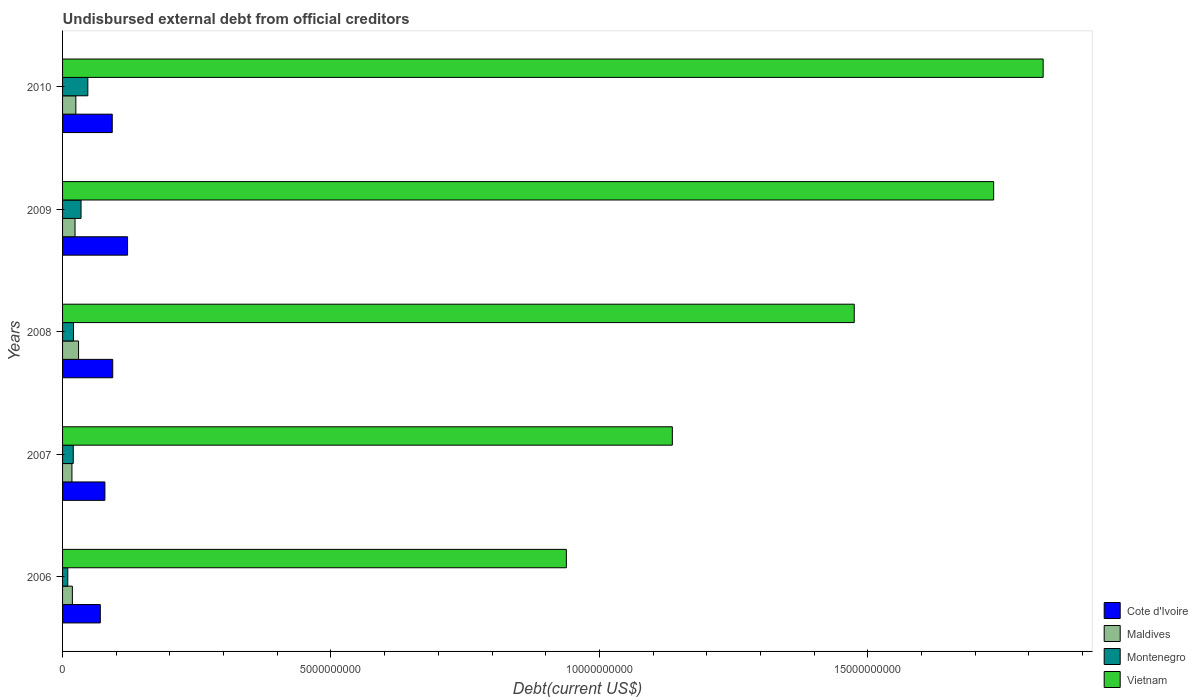How many different coloured bars are there?
Provide a short and direct response. 4. How many groups of bars are there?
Provide a short and direct response. 5. Are the number of bars on each tick of the Y-axis equal?
Keep it short and to the point. Yes. In how many cases, is the number of bars for a given year not equal to the number of legend labels?
Your answer should be very brief. 0. What is the total debt in Vietnam in 2008?
Ensure brevity in your answer.  1.47e+1. Across all years, what is the maximum total debt in Montenegro?
Your answer should be very brief. 4.71e+08. Across all years, what is the minimum total debt in Maldives?
Provide a short and direct response. 1.75e+08. In which year was the total debt in Maldives maximum?
Provide a succinct answer. 2008. In which year was the total debt in Cote d'Ivoire minimum?
Make the answer very short. 2006. What is the total total debt in Maldives in the graph?
Your answer should be very brief. 1.14e+09. What is the difference between the total debt in Cote d'Ivoire in 2007 and that in 2008?
Give a very brief answer. -1.46e+08. What is the difference between the total debt in Maldives in 2006 and the total debt in Montenegro in 2009?
Make the answer very short. -1.61e+08. What is the average total debt in Vietnam per year?
Ensure brevity in your answer.  1.42e+1. In the year 2009, what is the difference between the total debt in Maldives and total debt in Montenegro?
Give a very brief answer. -1.12e+08. In how many years, is the total debt in Cote d'Ivoire greater than 15000000000 US$?
Provide a succinct answer. 0. What is the ratio of the total debt in Montenegro in 2007 to that in 2010?
Give a very brief answer. 0.42. Is the total debt in Montenegro in 2008 less than that in 2009?
Your answer should be very brief. Yes. What is the difference between the highest and the second highest total debt in Montenegro?
Provide a short and direct response. 1.27e+08. What is the difference between the highest and the lowest total debt in Montenegro?
Your answer should be very brief. 3.74e+08. In how many years, is the total debt in Montenegro greater than the average total debt in Montenegro taken over all years?
Your response must be concise. 2. Is it the case that in every year, the sum of the total debt in Montenegro and total debt in Vietnam is greater than the sum of total debt in Cote d'Ivoire and total debt in Maldives?
Give a very brief answer. Yes. What does the 4th bar from the top in 2008 represents?
Offer a terse response. Cote d'Ivoire. What does the 1st bar from the bottom in 2006 represents?
Give a very brief answer. Cote d'Ivoire. Are all the bars in the graph horizontal?
Your answer should be very brief. Yes. How many years are there in the graph?
Keep it short and to the point. 5. Does the graph contain any zero values?
Keep it short and to the point. No. Does the graph contain grids?
Your response must be concise. No. Where does the legend appear in the graph?
Provide a succinct answer. Bottom right. How are the legend labels stacked?
Offer a very short reply. Vertical. What is the title of the graph?
Give a very brief answer. Undisbursed external debt from official creditors. Does "Zimbabwe" appear as one of the legend labels in the graph?
Offer a terse response. No. What is the label or title of the X-axis?
Provide a succinct answer. Debt(current US$). What is the label or title of the Y-axis?
Keep it short and to the point. Years. What is the Debt(current US$) of Cote d'Ivoire in 2006?
Ensure brevity in your answer.  7.03e+08. What is the Debt(current US$) in Maldives in 2006?
Give a very brief answer. 1.83e+08. What is the Debt(current US$) of Montenegro in 2006?
Your answer should be very brief. 9.70e+07. What is the Debt(current US$) in Vietnam in 2006?
Make the answer very short. 9.38e+09. What is the Debt(current US$) in Cote d'Ivoire in 2007?
Your answer should be compact. 7.89e+08. What is the Debt(current US$) in Maldives in 2007?
Give a very brief answer. 1.75e+08. What is the Debt(current US$) of Montenegro in 2007?
Provide a short and direct response. 1.99e+08. What is the Debt(current US$) of Vietnam in 2007?
Offer a terse response. 1.14e+1. What is the Debt(current US$) in Cote d'Ivoire in 2008?
Ensure brevity in your answer.  9.35e+08. What is the Debt(current US$) in Maldives in 2008?
Your answer should be compact. 2.98e+08. What is the Debt(current US$) in Montenegro in 2008?
Offer a terse response. 2.04e+08. What is the Debt(current US$) of Vietnam in 2008?
Make the answer very short. 1.47e+1. What is the Debt(current US$) in Cote d'Ivoire in 2009?
Offer a very short reply. 1.21e+09. What is the Debt(current US$) in Maldives in 2009?
Give a very brief answer. 2.32e+08. What is the Debt(current US$) in Montenegro in 2009?
Give a very brief answer. 3.44e+08. What is the Debt(current US$) of Vietnam in 2009?
Your answer should be very brief. 1.73e+1. What is the Debt(current US$) of Cote d'Ivoire in 2010?
Give a very brief answer. 9.25e+08. What is the Debt(current US$) of Maldives in 2010?
Give a very brief answer. 2.48e+08. What is the Debt(current US$) of Montenegro in 2010?
Offer a terse response. 4.71e+08. What is the Debt(current US$) in Vietnam in 2010?
Give a very brief answer. 1.83e+1. Across all years, what is the maximum Debt(current US$) in Cote d'Ivoire?
Your answer should be compact. 1.21e+09. Across all years, what is the maximum Debt(current US$) in Maldives?
Make the answer very short. 2.98e+08. Across all years, what is the maximum Debt(current US$) of Montenegro?
Give a very brief answer. 4.71e+08. Across all years, what is the maximum Debt(current US$) of Vietnam?
Give a very brief answer. 1.83e+1. Across all years, what is the minimum Debt(current US$) in Cote d'Ivoire?
Offer a terse response. 7.03e+08. Across all years, what is the minimum Debt(current US$) of Maldives?
Your response must be concise. 1.75e+08. Across all years, what is the minimum Debt(current US$) of Montenegro?
Your response must be concise. 9.70e+07. Across all years, what is the minimum Debt(current US$) in Vietnam?
Ensure brevity in your answer.  9.38e+09. What is the total Debt(current US$) of Cote d'Ivoire in the graph?
Your response must be concise. 4.56e+09. What is the total Debt(current US$) in Maldives in the graph?
Your answer should be very brief. 1.14e+09. What is the total Debt(current US$) of Montenegro in the graph?
Provide a succinct answer. 1.31e+09. What is the total Debt(current US$) of Vietnam in the graph?
Provide a succinct answer. 7.11e+1. What is the difference between the Debt(current US$) in Cote d'Ivoire in 2006 and that in 2007?
Offer a very short reply. -8.53e+07. What is the difference between the Debt(current US$) of Maldives in 2006 and that in 2007?
Provide a succinct answer. 8.20e+06. What is the difference between the Debt(current US$) of Montenegro in 2006 and that in 2007?
Give a very brief answer. -1.02e+08. What is the difference between the Debt(current US$) in Vietnam in 2006 and that in 2007?
Offer a terse response. -1.97e+09. What is the difference between the Debt(current US$) of Cote d'Ivoire in 2006 and that in 2008?
Offer a terse response. -2.31e+08. What is the difference between the Debt(current US$) of Maldives in 2006 and that in 2008?
Your answer should be compact. -1.15e+08. What is the difference between the Debt(current US$) in Montenegro in 2006 and that in 2008?
Provide a short and direct response. -1.07e+08. What is the difference between the Debt(current US$) in Vietnam in 2006 and that in 2008?
Make the answer very short. -5.36e+09. What is the difference between the Debt(current US$) of Cote d'Ivoire in 2006 and that in 2009?
Your response must be concise. -5.08e+08. What is the difference between the Debt(current US$) in Maldives in 2006 and that in 2009?
Provide a short and direct response. -4.94e+07. What is the difference between the Debt(current US$) in Montenegro in 2006 and that in 2009?
Offer a terse response. -2.47e+08. What is the difference between the Debt(current US$) in Vietnam in 2006 and that in 2009?
Offer a terse response. -7.96e+09. What is the difference between the Debt(current US$) of Cote d'Ivoire in 2006 and that in 2010?
Ensure brevity in your answer.  -2.22e+08. What is the difference between the Debt(current US$) of Maldives in 2006 and that in 2010?
Your answer should be very brief. -6.49e+07. What is the difference between the Debt(current US$) of Montenegro in 2006 and that in 2010?
Offer a terse response. -3.74e+08. What is the difference between the Debt(current US$) of Vietnam in 2006 and that in 2010?
Give a very brief answer. -8.88e+09. What is the difference between the Debt(current US$) in Cote d'Ivoire in 2007 and that in 2008?
Provide a short and direct response. -1.46e+08. What is the difference between the Debt(current US$) of Maldives in 2007 and that in 2008?
Offer a terse response. -1.24e+08. What is the difference between the Debt(current US$) of Montenegro in 2007 and that in 2008?
Provide a short and direct response. -4.64e+06. What is the difference between the Debt(current US$) of Vietnam in 2007 and that in 2008?
Your answer should be compact. -3.39e+09. What is the difference between the Debt(current US$) in Cote d'Ivoire in 2007 and that in 2009?
Provide a short and direct response. -4.22e+08. What is the difference between the Debt(current US$) of Maldives in 2007 and that in 2009?
Keep it short and to the point. -5.76e+07. What is the difference between the Debt(current US$) of Montenegro in 2007 and that in 2009?
Offer a terse response. -1.45e+08. What is the difference between the Debt(current US$) in Vietnam in 2007 and that in 2009?
Offer a terse response. -5.99e+09. What is the difference between the Debt(current US$) of Cote d'Ivoire in 2007 and that in 2010?
Ensure brevity in your answer.  -1.37e+08. What is the difference between the Debt(current US$) of Maldives in 2007 and that in 2010?
Your answer should be very brief. -7.31e+07. What is the difference between the Debt(current US$) in Montenegro in 2007 and that in 2010?
Your answer should be compact. -2.72e+08. What is the difference between the Debt(current US$) in Vietnam in 2007 and that in 2010?
Ensure brevity in your answer.  -6.91e+09. What is the difference between the Debt(current US$) of Cote d'Ivoire in 2008 and that in 2009?
Ensure brevity in your answer.  -2.76e+08. What is the difference between the Debt(current US$) in Maldives in 2008 and that in 2009?
Provide a short and direct response. 6.60e+07. What is the difference between the Debt(current US$) of Montenegro in 2008 and that in 2009?
Your answer should be compact. -1.40e+08. What is the difference between the Debt(current US$) of Vietnam in 2008 and that in 2009?
Keep it short and to the point. -2.60e+09. What is the difference between the Debt(current US$) of Cote d'Ivoire in 2008 and that in 2010?
Ensure brevity in your answer.  9.16e+06. What is the difference between the Debt(current US$) in Maldives in 2008 and that in 2010?
Your response must be concise. 5.04e+07. What is the difference between the Debt(current US$) of Montenegro in 2008 and that in 2010?
Provide a succinct answer. -2.67e+08. What is the difference between the Debt(current US$) of Vietnam in 2008 and that in 2010?
Provide a short and direct response. -3.52e+09. What is the difference between the Debt(current US$) of Cote d'Ivoire in 2009 and that in 2010?
Your response must be concise. 2.85e+08. What is the difference between the Debt(current US$) of Maldives in 2009 and that in 2010?
Ensure brevity in your answer.  -1.55e+07. What is the difference between the Debt(current US$) of Montenegro in 2009 and that in 2010?
Keep it short and to the point. -1.27e+08. What is the difference between the Debt(current US$) of Vietnam in 2009 and that in 2010?
Give a very brief answer. -9.22e+08. What is the difference between the Debt(current US$) in Cote d'Ivoire in 2006 and the Debt(current US$) in Maldives in 2007?
Provide a succinct answer. 5.29e+08. What is the difference between the Debt(current US$) in Cote d'Ivoire in 2006 and the Debt(current US$) in Montenegro in 2007?
Offer a very short reply. 5.04e+08. What is the difference between the Debt(current US$) of Cote d'Ivoire in 2006 and the Debt(current US$) of Vietnam in 2007?
Keep it short and to the point. -1.07e+1. What is the difference between the Debt(current US$) in Maldives in 2006 and the Debt(current US$) in Montenegro in 2007?
Offer a very short reply. -1.63e+07. What is the difference between the Debt(current US$) in Maldives in 2006 and the Debt(current US$) in Vietnam in 2007?
Make the answer very short. -1.12e+1. What is the difference between the Debt(current US$) in Montenegro in 2006 and the Debt(current US$) in Vietnam in 2007?
Ensure brevity in your answer.  -1.13e+1. What is the difference between the Debt(current US$) in Cote d'Ivoire in 2006 and the Debt(current US$) in Maldives in 2008?
Your response must be concise. 4.05e+08. What is the difference between the Debt(current US$) in Cote d'Ivoire in 2006 and the Debt(current US$) in Montenegro in 2008?
Your answer should be compact. 5.00e+08. What is the difference between the Debt(current US$) of Cote d'Ivoire in 2006 and the Debt(current US$) of Vietnam in 2008?
Provide a succinct answer. -1.40e+1. What is the difference between the Debt(current US$) of Maldives in 2006 and the Debt(current US$) of Montenegro in 2008?
Your response must be concise. -2.10e+07. What is the difference between the Debt(current US$) of Maldives in 2006 and the Debt(current US$) of Vietnam in 2008?
Your answer should be very brief. -1.46e+1. What is the difference between the Debt(current US$) in Montenegro in 2006 and the Debt(current US$) in Vietnam in 2008?
Make the answer very short. -1.47e+1. What is the difference between the Debt(current US$) in Cote d'Ivoire in 2006 and the Debt(current US$) in Maldives in 2009?
Provide a succinct answer. 4.71e+08. What is the difference between the Debt(current US$) in Cote d'Ivoire in 2006 and the Debt(current US$) in Montenegro in 2009?
Your response must be concise. 3.59e+08. What is the difference between the Debt(current US$) of Cote d'Ivoire in 2006 and the Debt(current US$) of Vietnam in 2009?
Keep it short and to the point. -1.66e+1. What is the difference between the Debt(current US$) of Maldives in 2006 and the Debt(current US$) of Montenegro in 2009?
Make the answer very short. -1.61e+08. What is the difference between the Debt(current US$) in Maldives in 2006 and the Debt(current US$) in Vietnam in 2009?
Your answer should be compact. -1.72e+1. What is the difference between the Debt(current US$) of Montenegro in 2006 and the Debt(current US$) of Vietnam in 2009?
Offer a very short reply. -1.72e+1. What is the difference between the Debt(current US$) in Cote d'Ivoire in 2006 and the Debt(current US$) in Maldives in 2010?
Offer a very short reply. 4.56e+08. What is the difference between the Debt(current US$) in Cote d'Ivoire in 2006 and the Debt(current US$) in Montenegro in 2010?
Your response must be concise. 2.33e+08. What is the difference between the Debt(current US$) of Cote d'Ivoire in 2006 and the Debt(current US$) of Vietnam in 2010?
Offer a terse response. -1.76e+1. What is the difference between the Debt(current US$) of Maldives in 2006 and the Debt(current US$) of Montenegro in 2010?
Offer a terse response. -2.88e+08. What is the difference between the Debt(current US$) in Maldives in 2006 and the Debt(current US$) in Vietnam in 2010?
Provide a short and direct response. -1.81e+1. What is the difference between the Debt(current US$) in Montenegro in 2006 and the Debt(current US$) in Vietnam in 2010?
Your answer should be very brief. -1.82e+1. What is the difference between the Debt(current US$) of Cote d'Ivoire in 2007 and the Debt(current US$) of Maldives in 2008?
Your answer should be very brief. 4.91e+08. What is the difference between the Debt(current US$) of Cote d'Ivoire in 2007 and the Debt(current US$) of Montenegro in 2008?
Make the answer very short. 5.85e+08. What is the difference between the Debt(current US$) in Cote d'Ivoire in 2007 and the Debt(current US$) in Vietnam in 2008?
Offer a terse response. -1.40e+1. What is the difference between the Debt(current US$) of Maldives in 2007 and the Debt(current US$) of Montenegro in 2008?
Give a very brief answer. -2.92e+07. What is the difference between the Debt(current US$) of Maldives in 2007 and the Debt(current US$) of Vietnam in 2008?
Offer a very short reply. -1.46e+1. What is the difference between the Debt(current US$) of Montenegro in 2007 and the Debt(current US$) of Vietnam in 2008?
Offer a very short reply. -1.45e+1. What is the difference between the Debt(current US$) of Cote d'Ivoire in 2007 and the Debt(current US$) of Maldives in 2009?
Your response must be concise. 5.57e+08. What is the difference between the Debt(current US$) in Cote d'Ivoire in 2007 and the Debt(current US$) in Montenegro in 2009?
Provide a succinct answer. 4.45e+08. What is the difference between the Debt(current US$) in Cote d'Ivoire in 2007 and the Debt(current US$) in Vietnam in 2009?
Give a very brief answer. -1.66e+1. What is the difference between the Debt(current US$) of Maldives in 2007 and the Debt(current US$) of Montenegro in 2009?
Give a very brief answer. -1.69e+08. What is the difference between the Debt(current US$) of Maldives in 2007 and the Debt(current US$) of Vietnam in 2009?
Offer a terse response. -1.72e+1. What is the difference between the Debt(current US$) of Montenegro in 2007 and the Debt(current US$) of Vietnam in 2009?
Make the answer very short. -1.71e+1. What is the difference between the Debt(current US$) in Cote d'Ivoire in 2007 and the Debt(current US$) in Maldives in 2010?
Make the answer very short. 5.41e+08. What is the difference between the Debt(current US$) in Cote d'Ivoire in 2007 and the Debt(current US$) in Montenegro in 2010?
Keep it short and to the point. 3.18e+08. What is the difference between the Debt(current US$) of Cote d'Ivoire in 2007 and the Debt(current US$) of Vietnam in 2010?
Provide a succinct answer. -1.75e+1. What is the difference between the Debt(current US$) in Maldives in 2007 and the Debt(current US$) in Montenegro in 2010?
Offer a very short reply. -2.96e+08. What is the difference between the Debt(current US$) of Maldives in 2007 and the Debt(current US$) of Vietnam in 2010?
Make the answer very short. -1.81e+1. What is the difference between the Debt(current US$) in Montenegro in 2007 and the Debt(current US$) in Vietnam in 2010?
Provide a short and direct response. -1.81e+1. What is the difference between the Debt(current US$) of Cote d'Ivoire in 2008 and the Debt(current US$) of Maldives in 2009?
Ensure brevity in your answer.  7.02e+08. What is the difference between the Debt(current US$) of Cote d'Ivoire in 2008 and the Debt(current US$) of Montenegro in 2009?
Offer a terse response. 5.91e+08. What is the difference between the Debt(current US$) of Cote d'Ivoire in 2008 and the Debt(current US$) of Vietnam in 2009?
Your answer should be compact. -1.64e+1. What is the difference between the Debt(current US$) of Maldives in 2008 and the Debt(current US$) of Montenegro in 2009?
Ensure brevity in your answer.  -4.59e+07. What is the difference between the Debt(current US$) in Maldives in 2008 and the Debt(current US$) in Vietnam in 2009?
Provide a succinct answer. -1.70e+1. What is the difference between the Debt(current US$) in Montenegro in 2008 and the Debt(current US$) in Vietnam in 2009?
Provide a short and direct response. -1.71e+1. What is the difference between the Debt(current US$) in Cote d'Ivoire in 2008 and the Debt(current US$) in Maldives in 2010?
Provide a succinct answer. 6.87e+08. What is the difference between the Debt(current US$) of Cote d'Ivoire in 2008 and the Debt(current US$) of Montenegro in 2010?
Your answer should be compact. 4.64e+08. What is the difference between the Debt(current US$) in Cote d'Ivoire in 2008 and the Debt(current US$) in Vietnam in 2010?
Your answer should be very brief. -1.73e+1. What is the difference between the Debt(current US$) in Maldives in 2008 and the Debt(current US$) in Montenegro in 2010?
Provide a succinct answer. -1.73e+08. What is the difference between the Debt(current US$) in Maldives in 2008 and the Debt(current US$) in Vietnam in 2010?
Make the answer very short. -1.80e+1. What is the difference between the Debt(current US$) in Montenegro in 2008 and the Debt(current US$) in Vietnam in 2010?
Give a very brief answer. -1.81e+1. What is the difference between the Debt(current US$) of Cote d'Ivoire in 2009 and the Debt(current US$) of Maldives in 2010?
Give a very brief answer. 9.63e+08. What is the difference between the Debt(current US$) of Cote d'Ivoire in 2009 and the Debt(current US$) of Montenegro in 2010?
Offer a very short reply. 7.40e+08. What is the difference between the Debt(current US$) of Cote d'Ivoire in 2009 and the Debt(current US$) of Vietnam in 2010?
Your answer should be compact. -1.71e+1. What is the difference between the Debt(current US$) of Maldives in 2009 and the Debt(current US$) of Montenegro in 2010?
Make the answer very short. -2.39e+08. What is the difference between the Debt(current US$) in Maldives in 2009 and the Debt(current US$) in Vietnam in 2010?
Provide a short and direct response. -1.80e+1. What is the difference between the Debt(current US$) in Montenegro in 2009 and the Debt(current US$) in Vietnam in 2010?
Provide a succinct answer. -1.79e+1. What is the average Debt(current US$) of Cote d'Ivoire per year?
Give a very brief answer. 9.13e+08. What is the average Debt(current US$) in Maldives per year?
Offer a very short reply. 2.27e+08. What is the average Debt(current US$) of Montenegro per year?
Provide a short and direct response. 2.63e+08. What is the average Debt(current US$) of Vietnam per year?
Offer a terse response. 1.42e+1. In the year 2006, what is the difference between the Debt(current US$) in Cote d'Ivoire and Debt(current US$) in Maldives?
Provide a short and direct response. 5.21e+08. In the year 2006, what is the difference between the Debt(current US$) of Cote d'Ivoire and Debt(current US$) of Montenegro?
Provide a short and direct response. 6.06e+08. In the year 2006, what is the difference between the Debt(current US$) in Cote d'Ivoire and Debt(current US$) in Vietnam?
Your answer should be compact. -8.68e+09. In the year 2006, what is the difference between the Debt(current US$) of Maldives and Debt(current US$) of Montenegro?
Provide a short and direct response. 8.57e+07. In the year 2006, what is the difference between the Debt(current US$) of Maldives and Debt(current US$) of Vietnam?
Your response must be concise. -9.20e+09. In the year 2006, what is the difference between the Debt(current US$) of Montenegro and Debt(current US$) of Vietnam?
Provide a short and direct response. -9.29e+09. In the year 2007, what is the difference between the Debt(current US$) in Cote d'Ivoire and Debt(current US$) in Maldives?
Offer a very short reply. 6.14e+08. In the year 2007, what is the difference between the Debt(current US$) in Cote d'Ivoire and Debt(current US$) in Montenegro?
Keep it short and to the point. 5.90e+08. In the year 2007, what is the difference between the Debt(current US$) of Cote d'Ivoire and Debt(current US$) of Vietnam?
Provide a short and direct response. -1.06e+1. In the year 2007, what is the difference between the Debt(current US$) in Maldives and Debt(current US$) in Montenegro?
Provide a succinct answer. -2.45e+07. In the year 2007, what is the difference between the Debt(current US$) of Maldives and Debt(current US$) of Vietnam?
Ensure brevity in your answer.  -1.12e+1. In the year 2007, what is the difference between the Debt(current US$) in Montenegro and Debt(current US$) in Vietnam?
Keep it short and to the point. -1.12e+1. In the year 2008, what is the difference between the Debt(current US$) of Cote d'Ivoire and Debt(current US$) of Maldives?
Offer a terse response. 6.36e+08. In the year 2008, what is the difference between the Debt(current US$) of Cote d'Ivoire and Debt(current US$) of Montenegro?
Keep it short and to the point. 7.31e+08. In the year 2008, what is the difference between the Debt(current US$) in Cote d'Ivoire and Debt(current US$) in Vietnam?
Your answer should be compact. -1.38e+1. In the year 2008, what is the difference between the Debt(current US$) of Maldives and Debt(current US$) of Montenegro?
Keep it short and to the point. 9.44e+07. In the year 2008, what is the difference between the Debt(current US$) in Maldives and Debt(current US$) in Vietnam?
Your response must be concise. -1.44e+1. In the year 2008, what is the difference between the Debt(current US$) in Montenegro and Debt(current US$) in Vietnam?
Your answer should be very brief. -1.45e+1. In the year 2009, what is the difference between the Debt(current US$) in Cote d'Ivoire and Debt(current US$) in Maldives?
Keep it short and to the point. 9.79e+08. In the year 2009, what is the difference between the Debt(current US$) of Cote d'Ivoire and Debt(current US$) of Montenegro?
Offer a terse response. 8.67e+08. In the year 2009, what is the difference between the Debt(current US$) of Cote d'Ivoire and Debt(current US$) of Vietnam?
Make the answer very short. -1.61e+1. In the year 2009, what is the difference between the Debt(current US$) of Maldives and Debt(current US$) of Montenegro?
Your response must be concise. -1.12e+08. In the year 2009, what is the difference between the Debt(current US$) of Maldives and Debt(current US$) of Vietnam?
Provide a short and direct response. -1.71e+1. In the year 2009, what is the difference between the Debt(current US$) in Montenegro and Debt(current US$) in Vietnam?
Offer a terse response. -1.70e+1. In the year 2010, what is the difference between the Debt(current US$) of Cote d'Ivoire and Debt(current US$) of Maldives?
Make the answer very short. 6.78e+08. In the year 2010, what is the difference between the Debt(current US$) of Cote d'Ivoire and Debt(current US$) of Montenegro?
Your response must be concise. 4.55e+08. In the year 2010, what is the difference between the Debt(current US$) of Cote d'Ivoire and Debt(current US$) of Vietnam?
Ensure brevity in your answer.  -1.73e+1. In the year 2010, what is the difference between the Debt(current US$) in Maldives and Debt(current US$) in Montenegro?
Make the answer very short. -2.23e+08. In the year 2010, what is the difference between the Debt(current US$) of Maldives and Debt(current US$) of Vietnam?
Offer a very short reply. -1.80e+1. In the year 2010, what is the difference between the Debt(current US$) of Montenegro and Debt(current US$) of Vietnam?
Make the answer very short. -1.78e+1. What is the ratio of the Debt(current US$) in Cote d'Ivoire in 2006 to that in 2007?
Your answer should be very brief. 0.89. What is the ratio of the Debt(current US$) in Maldives in 2006 to that in 2007?
Make the answer very short. 1.05. What is the ratio of the Debt(current US$) in Montenegro in 2006 to that in 2007?
Keep it short and to the point. 0.49. What is the ratio of the Debt(current US$) of Vietnam in 2006 to that in 2007?
Offer a terse response. 0.83. What is the ratio of the Debt(current US$) of Cote d'Ivoire in 2006 to that in 2008?
Offer a terse response. 0.75. What is the ratio of the Debt(current US$) in Maldives in 2006 to that in 2008?
Provide a succinct answer. 0.61. What is the ratio of the Debt(current US$) in Montenegro in 2006 to that in 2008?
Offer a terse response. 0.48. What is the ratio of the Debt(current US$) in Vietnam in 2006 to that in 2008?
Your answer should be compact. 0.64. What is the ratio of the Debt(current US$) of Cote d'Ivoire in 2006 to that in 2009?
Your response must be concise. 0.58. What is the ratio of the Debt(current US$) of Maldives in 2006 to that in 2009?
Offer a terse response. 0.79. What is the ratio of the Debt(current US$) of Montenegro in 2006 to that in 2009?
Your answer should be compact. 0.28. What is the ratio of the Debt(current US$) of Vietnam in 2006 to that in 2009?
Offer a terse response. 0.54. What is the ratio of the Debt(current US$) in Cote d'Ivoire in 2006 to that in 2010?
Your answer should be very brief. 0.76. What is the ratio of the Debt(current US$) of Maldives in 2006 to that in 2010?
Ensure brevity in your answer.  0.74. What is the ratio of the Debt(current US$) of Montenegro in 2006 to that in 2010?
Offer a very short reply. 0.21. What is the ratio of the Debt(current US$) in Vietnam in 2006 to that in 2010?
Offer a very short reply. 0.51. What is the ratio of the Debt(current US$) of Cote d'Ivoire in 2007 to that in 2008?
Provide a succinct answer. 0.84. What is the ratio of the Debt(current US$) of Maldives in 2007 to that in 2008?
Offer a very short reply. 0.59. What is the ratio of the Debt(current US$) of Montenegro in 2007 to that in 2008?
Give a very brief answer. 0.98. What is the ratio of the Debt(current US$) of Vietnam in 2007 to that in 2008?
Provide a succinct answer. 0.77. What is the ratio of the Debt(current US$) of Cote d'Ivoire in 2007 to that in 2009?
Offer a very short reply. 0.65. What is the ratio of the Debt(current US$) in Maldives in 2007 to that in 2009?
Offer a terse response. 0.75. What is the ratio of the Debt(current US$) in Montenegro in 2007 to that in 2009?
Make the answer very short. 0.58. What is the ratio of the Debt(current US$) in Vietnam in 2007 to that in 2009?
Provide a succinct answer. 0.65. What is the ratio of the Debt(current US$) of Cote d'Ivoire in 2007 to that in 2010?
Offer a very short reply. 0.85. What is the ratio of the Debt(current US$) of Maldives in 2007 to that in 2010?
Make the answer very short. 0.7. What is the ratio of the Debt(current US$) of Montenegro in 2007 to that in 2010?
Offer a very short reply. 0.42. What is the ratio of the Debt(current US$) in Vietnam in 2007 to that in 2010?
Your answer should be compact. 0.62. What is the ratio of the Debt(current US$) of Cote d'Ivoire in 2008 to that in 2009?
Make the answer very short. 0.77. What is the ratio of the Debt(current US$) of Maldives in 2008 to that in 2009?
Your answer should be compact. 1.28. What is the ratio of the Debt(current US$) in Montenegro in 2008 to that in 2009?
Offer a terse response. 0.59. What is the ratio of the Debt(current US$) in Vietnam in 2008 to that in 2009?
Your answer should be very brief. 0.85. What is the ratio of the Debt(current US$) in Cote d'Ivoire in 2008 to that in 2010?
Your answer should be compact. 1.01. What is the ratio of the Debt(current US$) in Maldives in 2008 to that in 2010?
Offer a terse response. 1.2. What is the ratio of the Debt(current US$) in Montenegro in 2008 to that in 2010?
Keep it short and to the point. 0.43. What is the ratio of the Debt(current US$) of Vietnam in 2008 to that in 2010?
Your answer should be compact. 0.81. What is the ratio of the Debt(current US$) in Cote d'Ivoire in 2009 to that in 2010?
Give a very brief answer. 1.31. What is the ratio of the Debt(current US$) in Maldives in 2009 to that in 2010?
Ensure brevity in your answer.  0.94. What is the ratio of the Debt(current US$) in Montenegro in 2009 to that in 2010?
Give a very brief answer. 0.73. What is the ratio of the Debt(current US$) in Vietnam in 2009 to that in 2010?
Provide a succinct answer. 0.95. What is the difference between the highest and the second highest Debt(current US$) of Cote d'Ivoire?
Offer a very short reply. 2.76e+08. What is the difference between the highest and the second highest Debt(current US$) of Maldives?
Provide a succinct answer. 5.04e+07. What is the difference between the highest and the second highest Debt(current US$) of Montenegro?
Your answer should be very brief. 1.27e+08. What is the difference between the highest and the second highest Debt(current US$) of Vietnam?
Provide a succinct answer. 9.22e+08. What is the difference between the highest and the lowest Debt(current US$) of Cote d'Ivoire?
Make the answer very short. 5.08e+08. What is the difference between the highest and the lowest Debt(current US$) of Maldives?
Provide a succinct answer. 1.24e+08. What is the difference between the highest and the lowest Debt(current US$) of Montenegro?
Your answer should be very brief. 3.74e+08. What is the difference between the highest and the lowest Debt(current US$) in Vietnam?
Your answer should be very brief. 8.88e+09. 